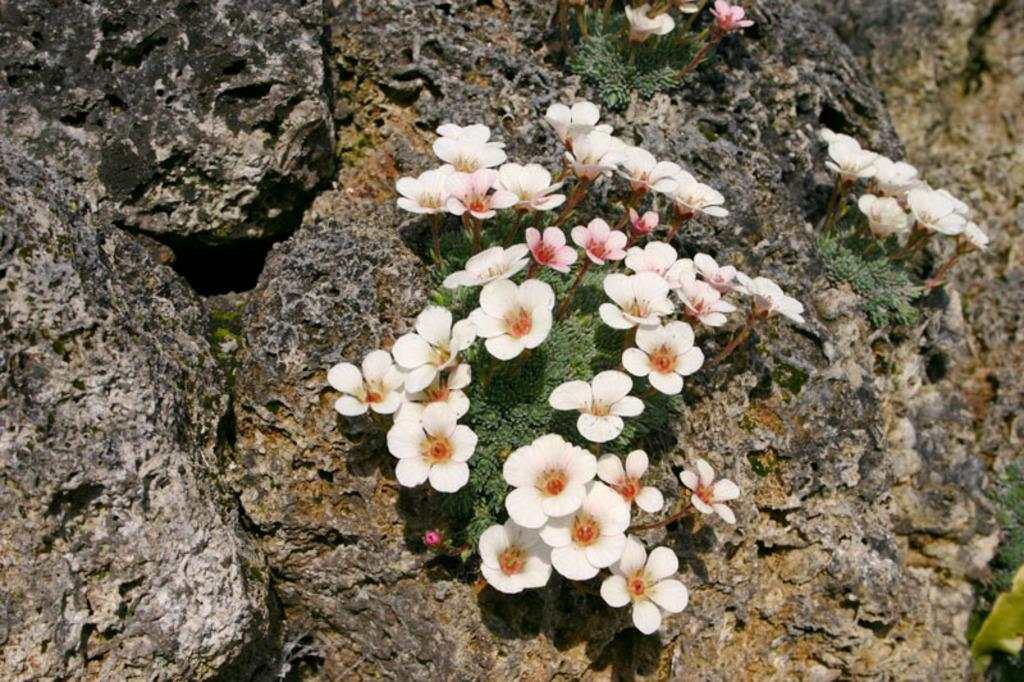What is present in the image? There are flowers in the image. Where are the flowers located? The flowers are on a rock. How many dogs are carrying a parcel in the image? There are no dogs or parcels present in the image; it features flowers on a rock. 